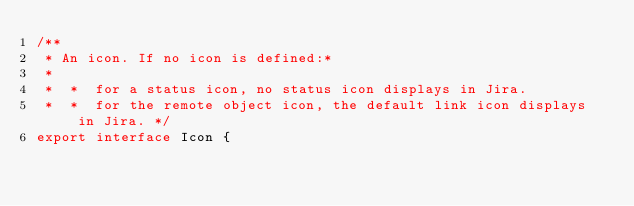Convert code to text. <code><loc_0><loc_0><loc_500><loc_500><_TypeScript_>/**
 * An icon. If no icon is defined:*
 *
 *  *  for a status icon, no status icon displays in Jira.
 *  *  for the remote object icon, the default link icon displays in Jira. */
export interface Icon {</code> 